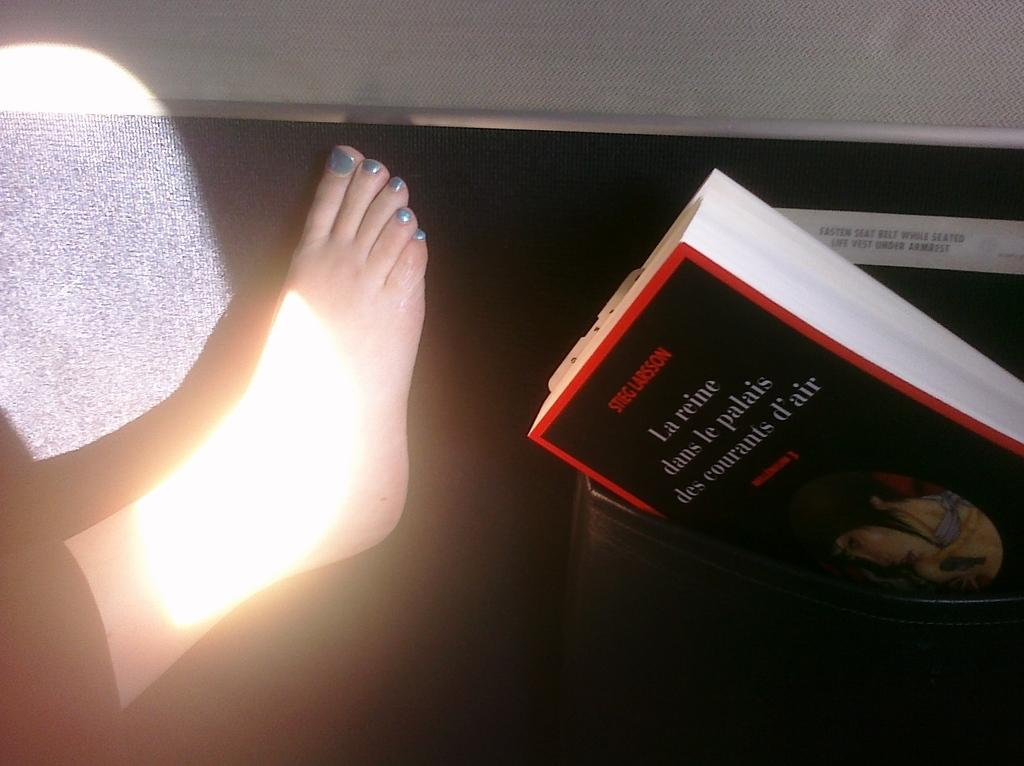<image>
Describe the image concisely. A book by Stieg Larsson can be seen by a foot. 